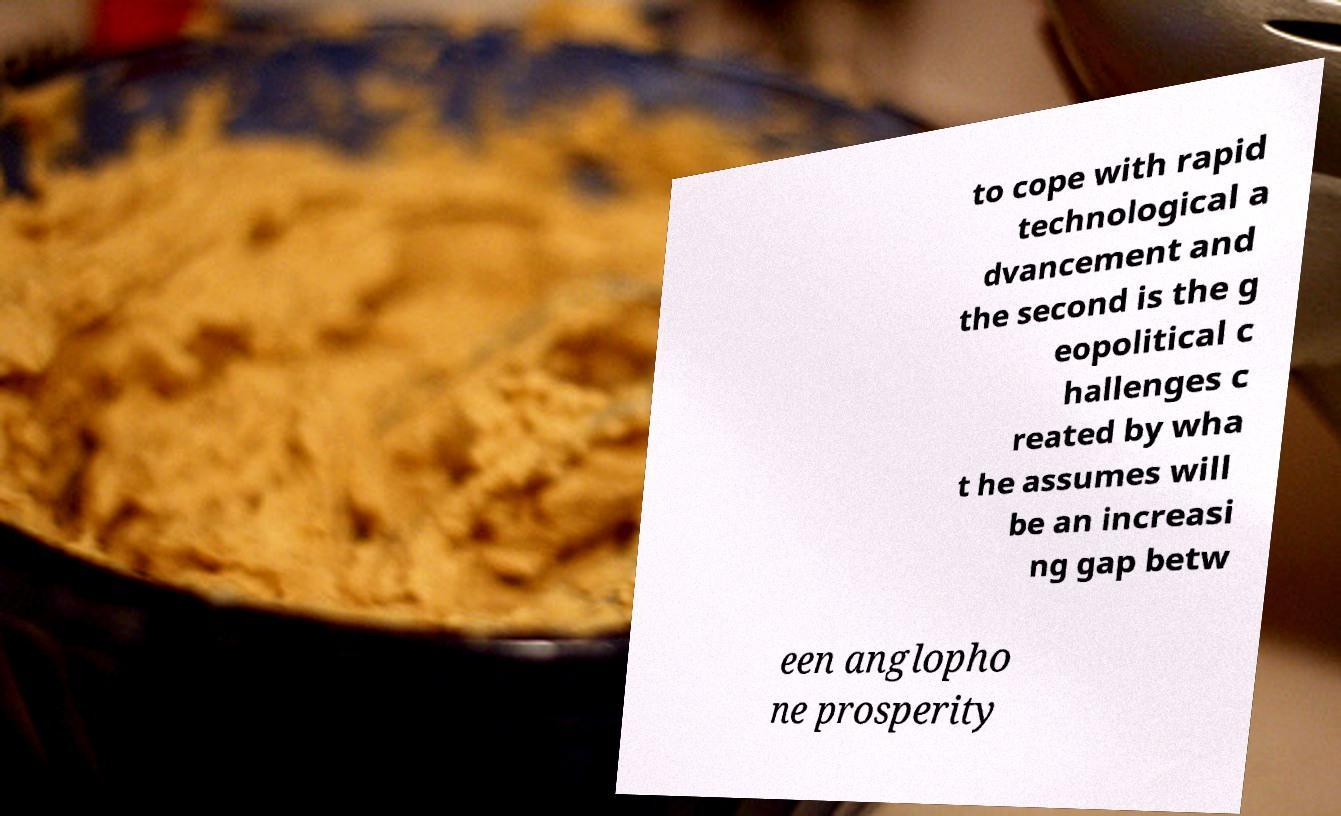Please identify and transcribe the text found in this image. to cope with rapid technological a dvancement and the second is the g eopolitical c hallenges c reated by wha t he assumes will be an increasi ng gap betw een anglopho ne prosperity 